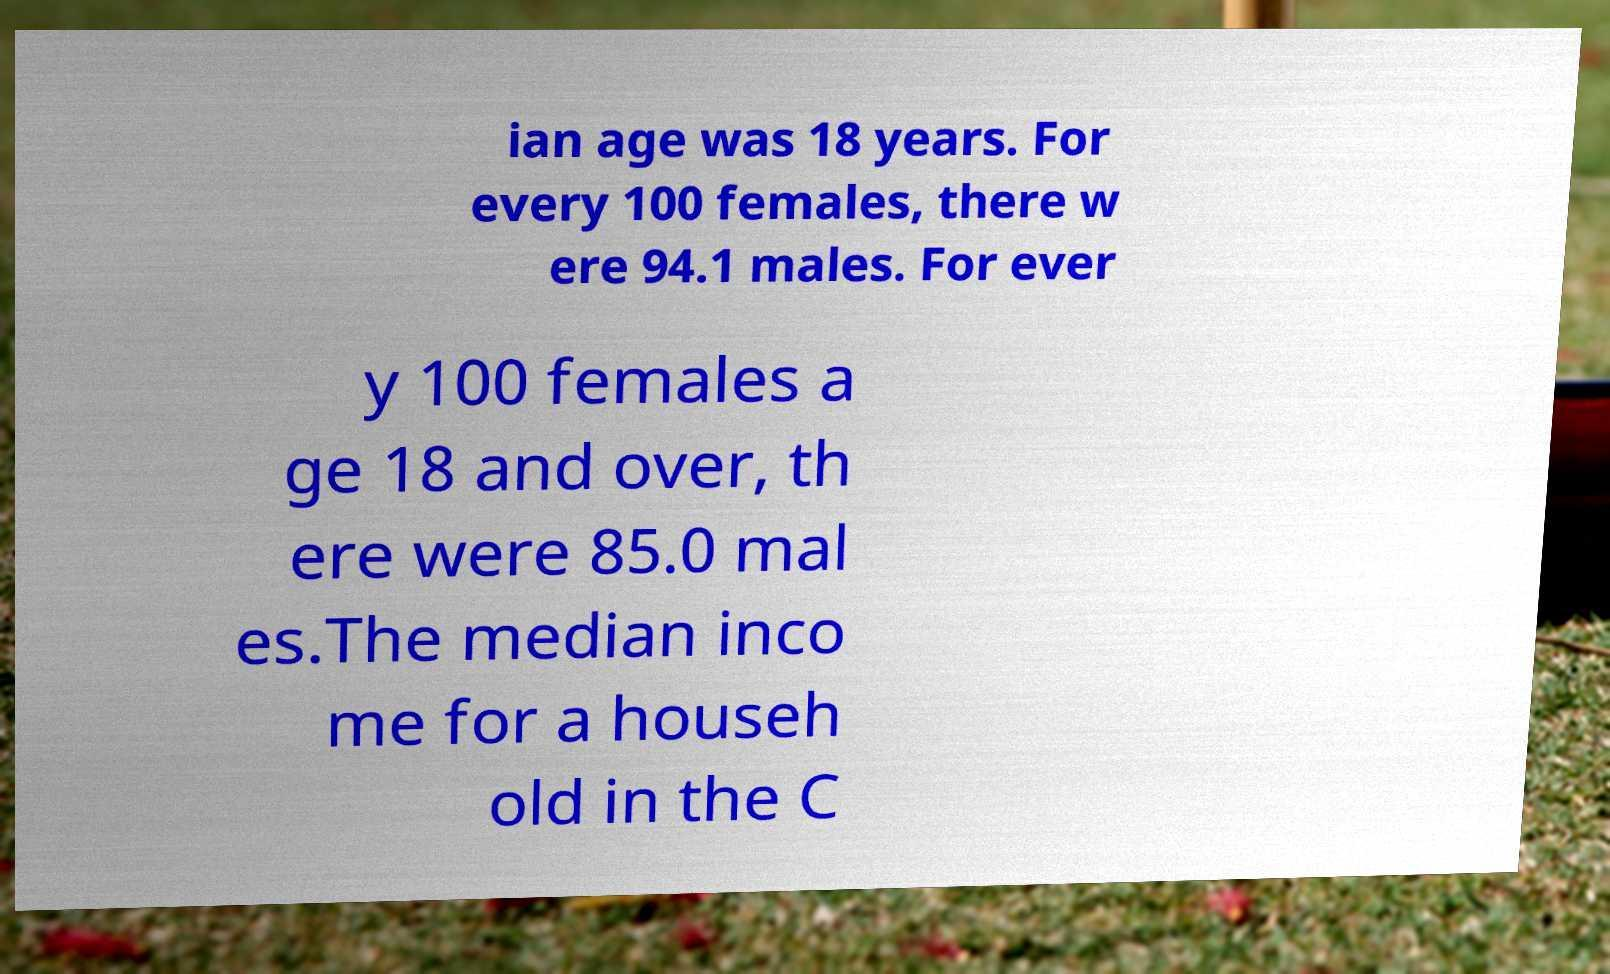Could you assist in decoding the text presented in this image and type it out clearly? ian age was 18 years. For every 100 females, there w ere 94.1 males. For ever y 100 females a ge 18 and over, th ere were 85.0 mal es.The median inco me for a househ old in the C 